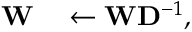Convert formula to latex. <formula><loc_0><loc_0><loc_500><loc_500>\begin{array} { r l } { W } & \leftarrow W D ^ { - 1 } , } \end{array}</formula> 